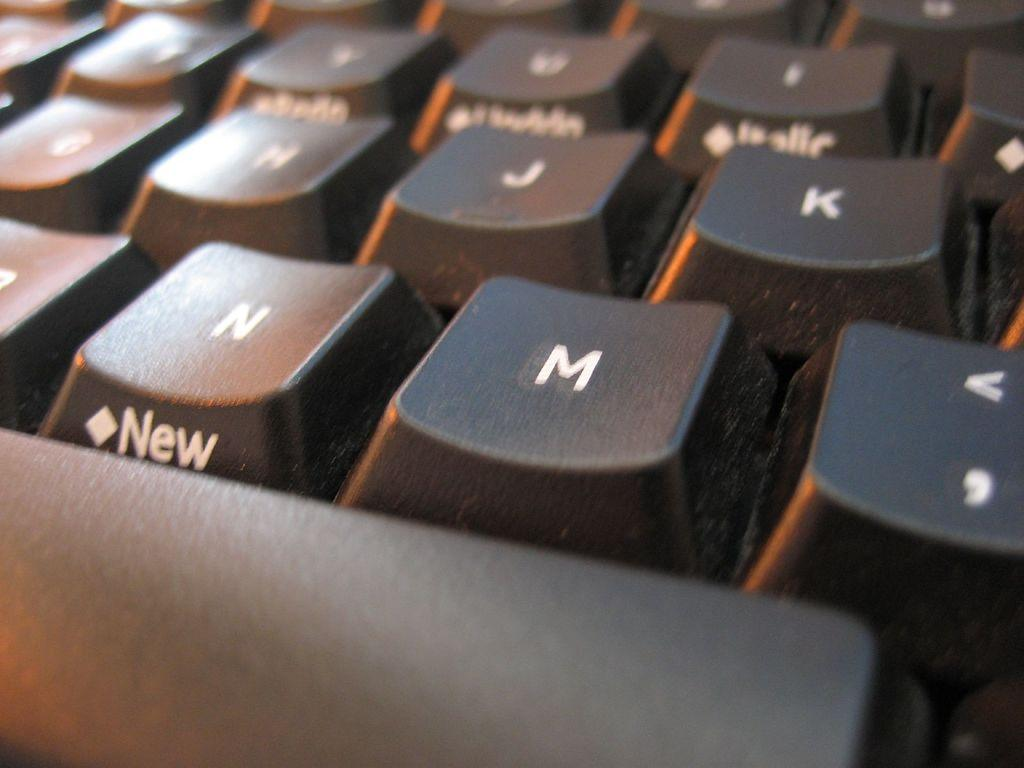Provide a one-sentence caption for the provided image. a keyboard with the word 'new' on the side of key 'n'. 